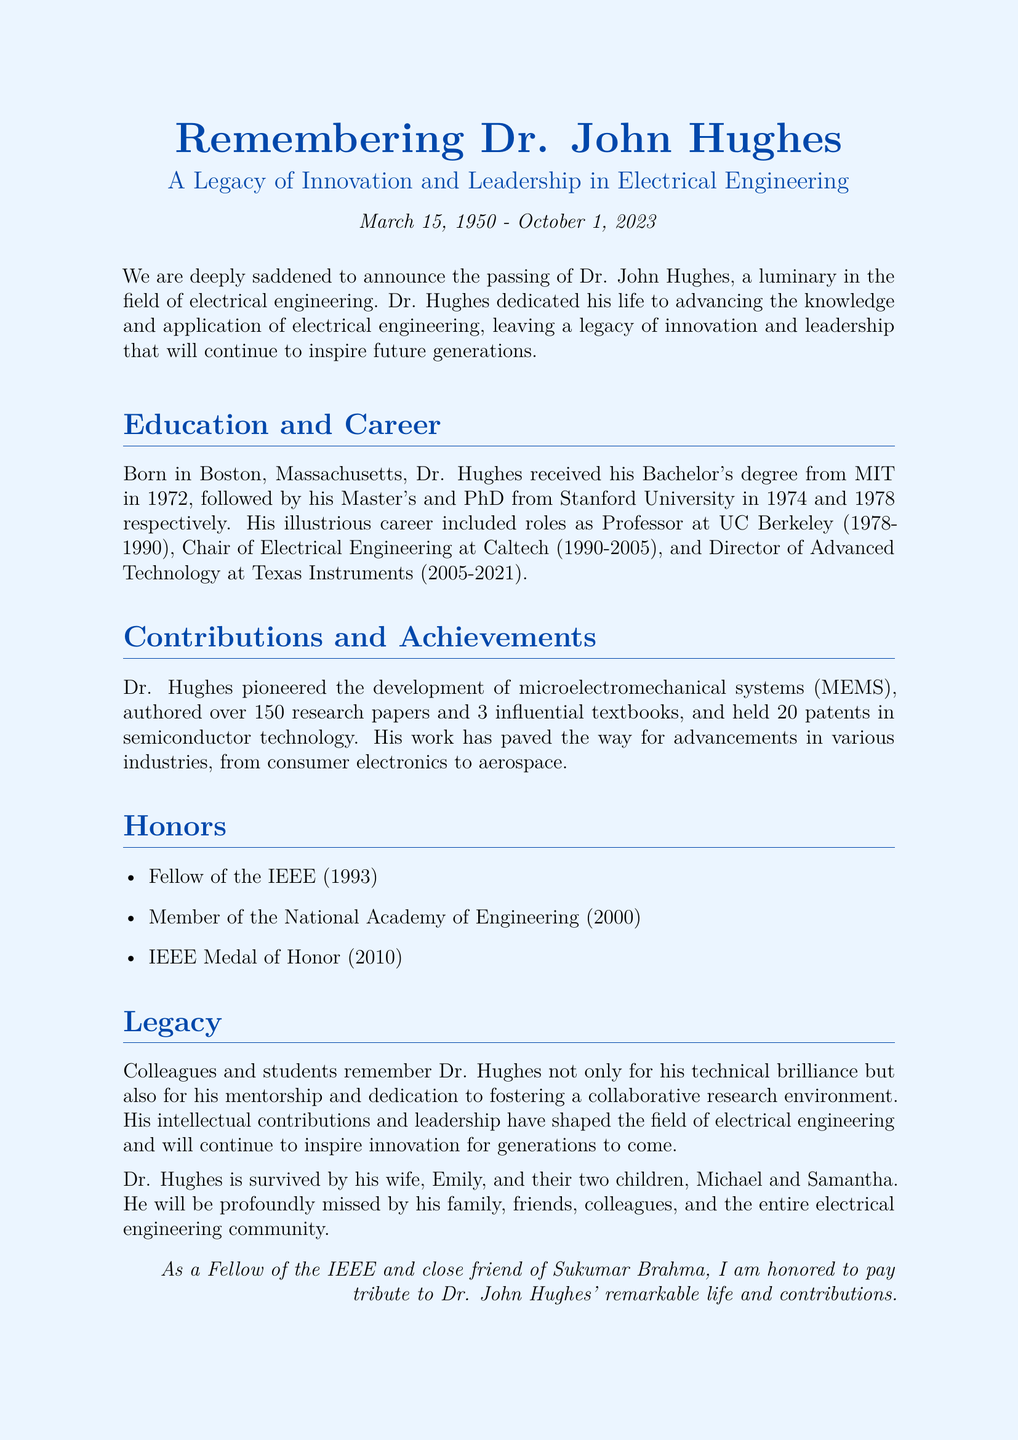What is Dr. John Hughes' date of birth? Dr. Hughes was born on March 15, 1950, as stated in the document.
Answer: March 15, 1950 When did Dr. Hughes pass away? The document states that Dr. Hughes passed away on October 1, 2023.
Answer: October 1, 2023 How many research papers did Dr. Hughes author? The obituary mentions that Dr. Hughes authored over 150 research papers.
Answer: over 150 What prestigious recognition did Dr. Hughes receive in 2010? According to the document, he received the IEEE Medal of Honor in 2010.
Answer: IEEE Medal of Honor Which university did Dr. Hughes attend for his Bachelor's degree? The document states that Dr. Hughes received his Bachelor's degree from MIT.
Answer: MIT What field did Dr. Hughes primarily contribute to? The document highlights that Dr. Hughes was a luminary in the field of electrical engineering.
Answer: electrical engineering How did Dr. Hughes influence his colleagues and students? The obituary emphasizes that he was remembered for his mentorship and dedication to fostering a collaborative research environment.
Answer: mentorship and collaborative research environment What technology did Dr. Hughes pioneer? The document states that Dr. Hughes pioneered the development of microelectromechanical systems (MEMS).
Answer: microelectromechanical systems (MEMS) How long did Dr. Hughes serve as Director of Advanced Technology at Texas Instruments? The document indicates that he served from 2005 to 2021, which totals 16 years.
Answer: 16 years 